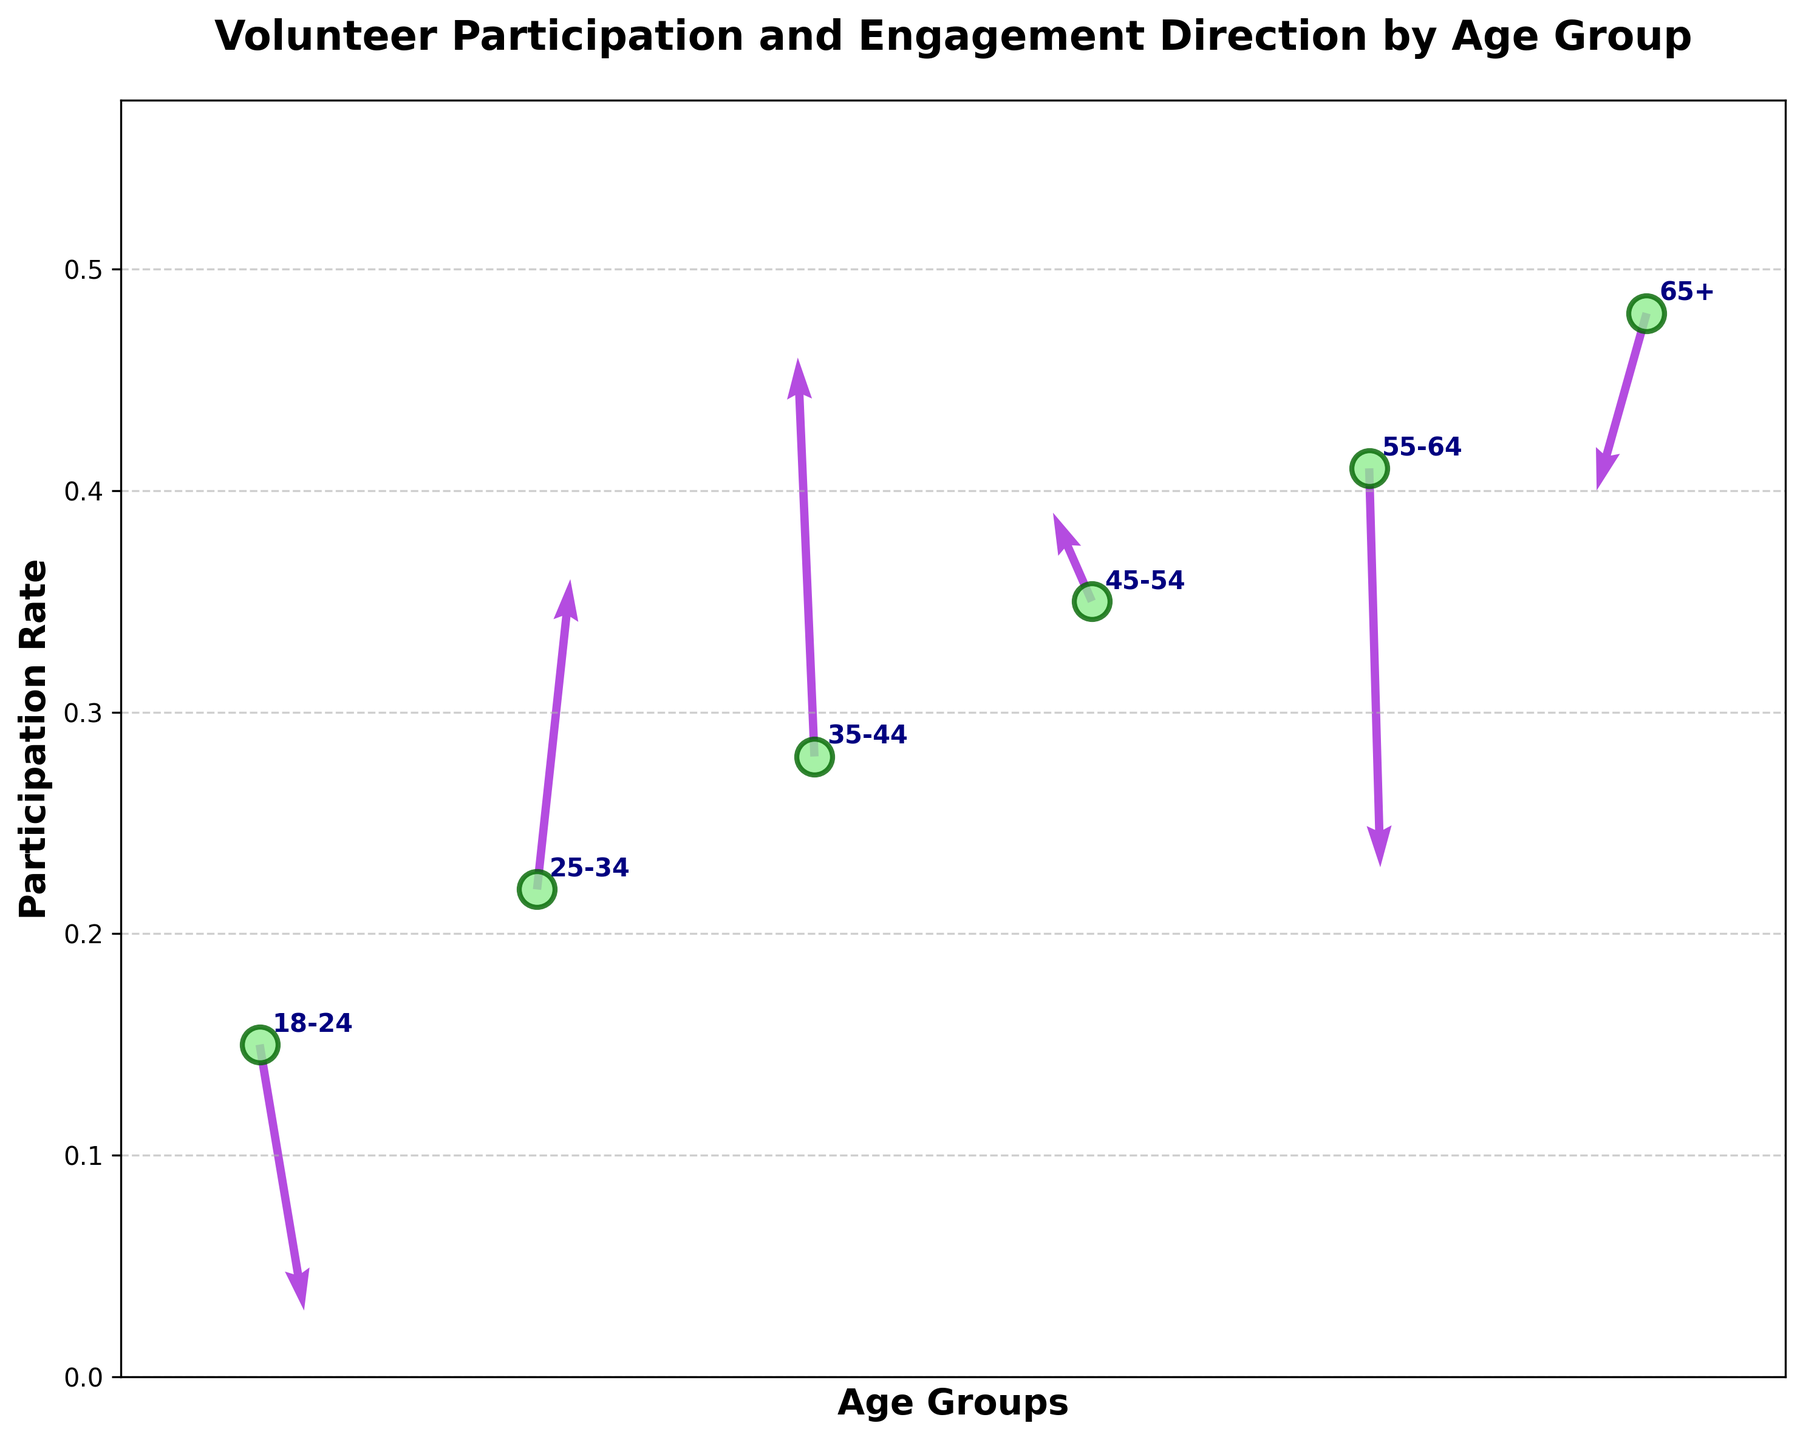What's the title of the plot? The title is positioned at the top of the plot. It reads, "Volunteer Participation and Engagement Direction by Age Group."
Answer: Volunteer Participation and Engagement Direction by Age Group Which age group has the lowest participation rate? By looking at the y-axis and finding the lowest point on the vertical axis, the age group with the label "18-24" has the lowest participation rate.
Answer: 18-24 What is the participation rate for the 45-54 age group? Find the 45-54 age group label on the x-axis and locate its corresponding y-value. The dot aligns with a y-value of 0.35.
Answer: 0.35 How many age groups are represented in the plot? Count the number of unique age group labels annotated on the plot. There are six age groups: 18-24, 25-34, 35-44, 45-54, 55-64, and 65+.
Answer: 6 Which age group has the direction vector pointing most towards the upper-left? The upper-left direction is characterized by a negative x-component and a positive y-component. The age group 35-44 has the vector (-0.3, 0.9) which best fits this description.
Answer: 35-44 Compare the participation rates for the 25-34 and 55-64 age groups. Which is greater and by how much? The participation rate for the 25-34 age group is 0.22 and for the 55-64 age group is 0.41. The difference is 0.41 - 0.22 = 0.19.
Answer: 55-64 by 0.19 Which age group has the steepest downward engagement direction? The steepest downward direction corresponds to the largest negative y-component. The age group 55-64 has the largest negative y-component (-0.9).
Answer: 55-64 What is the overall trend in participation rates as age increases? Observing the y-values and corresponding age groups in ascending order from 18-24 to 65+, the participation rate increases with age.
Answer: Increases with age Is there any age group whose engagement direction predominantly points rightward? The rightward direction indicates a positive x-component. The age group 18-24 (0.8, -0.6) points predominantly towards the right.
Answer: 18-24 